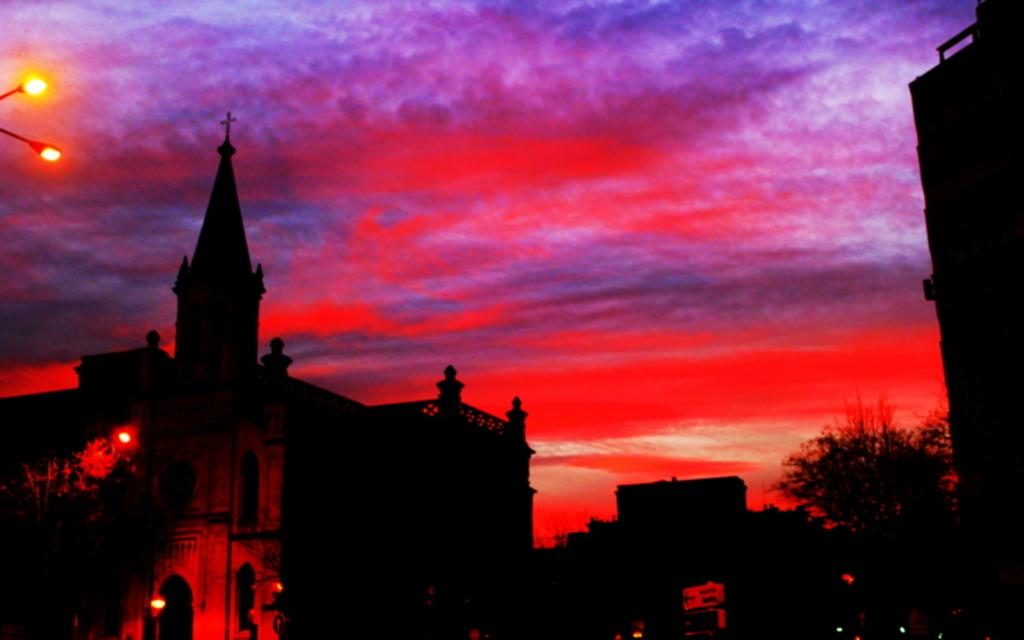What type of structures can be seen in the image? There are buildings in the image. What other natural elements are present in the image? There are trees in the image. Are there any artificial light sources visible in the image? Yes, there are lights in the image. What is the color of the sky in the background of the image? The sky is red in color in the background of the image. Can you see any clams in the image? No, there are no clams present in the image. What type of donkey can be seen interacting with the trees in the image? There is no donkey present in the image; it only features buildings, trees, lights, and a red sky. 